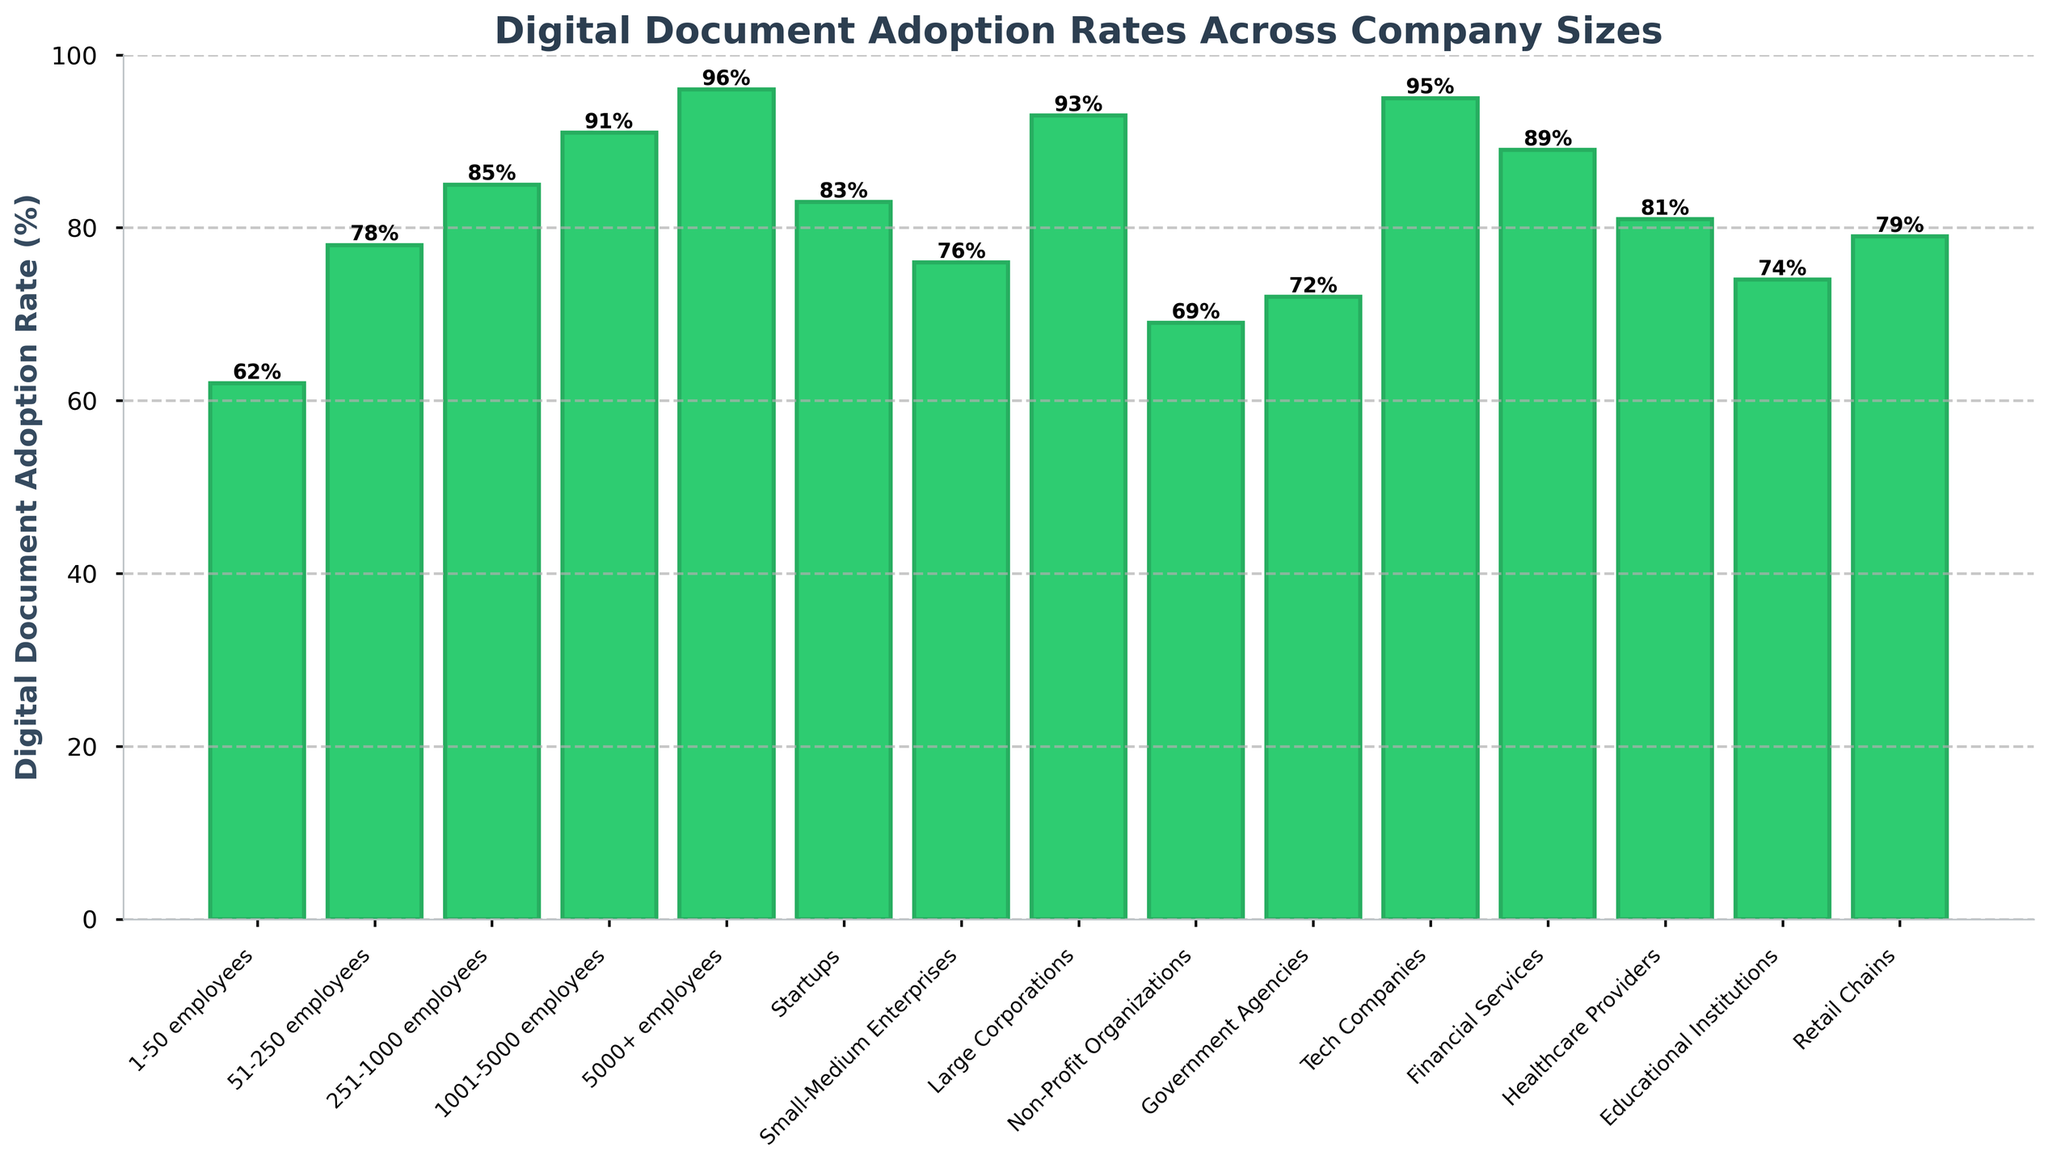What's the digital document adoption rate for large corporations? Locate the bar labeled 'Large Corporations' and read the height, which is the adoption rate. It is 93%.
Answer: 93% Which company size has the highest digital document adoption rate? Identify and compare the heights of all bars. The bar with the highest value is '5000+ employees' with a rate of 96%.
Answer: 5000+ employees Compare the digital document adoption rates of startups and small-medium enterprises. Which is higher? Locate the bars for 'Startups' and 'Small-Medium Enterprises', compare their heights. Startups have an adoption rate of 83% while Small-Medium Enterprises have 76%.
Answer: Startups What is the difference in digital document adoption rates between healthcare providers and educational institutions? Locate the bars for 'Healthcare Providers' and 'Educational Institutions'. Subtract the height of 'Educational Institutions' (74%) from 'Healthcare Providers' (81%). 81% - 74% = 7%.
Answer: 7% Which company size has the lowest digital document adoption rate and what is that rate? Identify the bar with the smallest height. '1-50 employees' has the lowest adoption rate at 62%.
Answer: 1-50 employees, 62% What is the average digital document adoption rate for companies with 51-250 employees, 1001-5000 employees, and tech companies? Locate the bars for '51-250 employees' (78%), '1001-5000 employees' (91%), and 'Tech Companies' (95%). Calculate the average by adding these rates and dividing by 3. (78 + 91 + 95) / 3 = 88%.
Answer: 88% Is the digital document adoption rate of government agencies greater than that of non-profit organizations? Compare the heights of the bars for 'Government Agencies' (72%) and 'Non-Profit Organizations' (69%). 72% is greater than 69%.
Answer: Yes Which has a higher adoption rate, financial services or educational institutions? Compare the heights of the bars for 'Financial Services' (89%) and 'Educational Institutions' (74%). Financial services have a higher rate.
Answer: Financial Services What's the median digital document adoption rate for the given data? List the adoption rates and find the middle value in the sorted list: [62, 69, 72, 74, 76, 78, 79, 81, 83, 85, 89, 91, 93, 95, 96]. The median is the 8th value which is 81%.
Answer: 81% By what percentage is the digital document adoption rate of tech companies higher than retail chains? Locate the bars for 'Tech Companies' (95%) and 'Retail Chains' (79%). Subtract the rate of 'Retail Chains' from 'Tech Companies' and divide by the rate of 'Retail Chains', then multiply by 100. [(95-79) / 79] * 100 = 20.25%.
Answer: 20.25% 